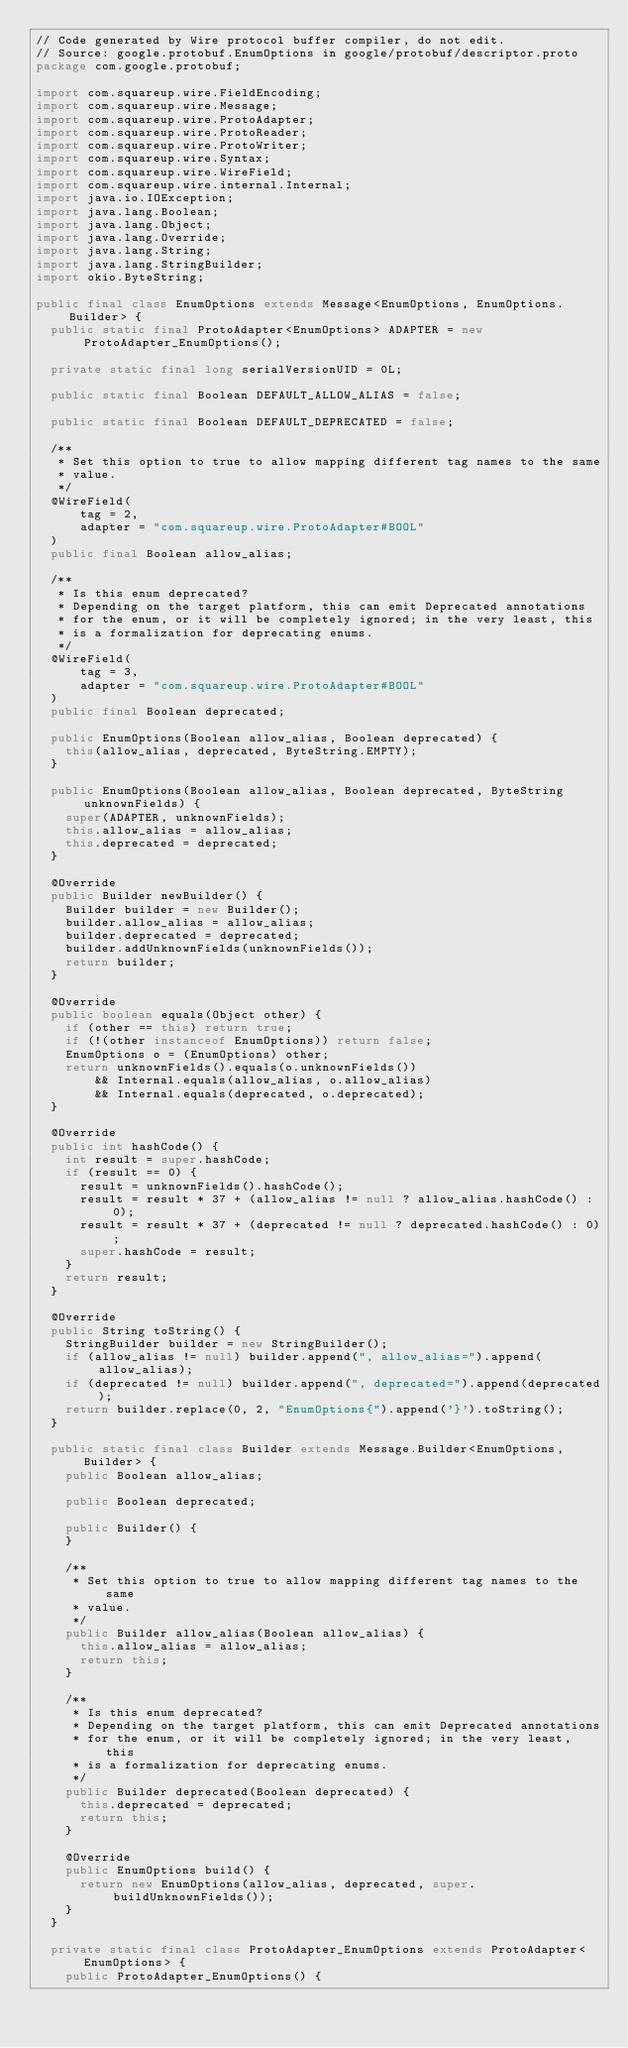Convert code to text. <code><loc_0><loc_0><loc_500><loc_500><_Java_>// Code generated by Wire protocol buffer compiler, do not edit.
// Source: google.protobuf.EnumOptions in google/protobuf/descriptor.proto
package com.google.protobuf;

import com.squareup.wire.FieldEncoding;
import com.squareup.wire.Message;
import com.squareup.wire.ProtoAdapter;
import com.squareup.wire.ProtoReader;
import com.squareup.wire.ProtoWriter;
import com.squareup.wire.Syntax;
import com.squareup.wire.WireField;
import com.squareup.wire.internal.Internal;
import java.io.IOException;
import java.lang.Boolean;
import java.lang.Object;
import java.lang.Override;
import java.lang.String;
import java.lang.StringBuilder;
import okio.ByteString;

public final class EnumOptions extends Message<EnumOptions, EnumOptions.Builder> {
  public static final ProtoAdapter<EnumOptions> ADAPTER = new ProtoAdapter_EnumOptions();

  private static final long serialVersionUID = 0L;

  public static final Boolean DEFAULT_ALLOW_ALIAS = false;

  public static final Boolean DEFAULT_DEPRECATED = false;

  /**
   * Set this option to true to allow mapping different tag names to the same
   * value.
   */
  @WireField(
      tag = 2,
      adapter = "com.squareup.wire.ProtoAdapter#BOOL"
  )
  public final Boolean allow_alias;

  /**
   * Is this enum deprecated?
   * Depending on the target platform, this can emit Deprecated annotations
   * for the enum, or it will be completely ignored; in the very least, this
   * is a formalization for deprecating enums.
   */
  @WireField(
      tag = 3,
      adapter = "com.squareup.wire.ProtoAdapter#BOOL"
  )
  public final Boolean deprecated;

  public EnumOptions(Boolean allow_alias, Boolean deprecated) {
    this(allow_alias, deprecated, ByteString.EMPTY);
  }

  public EnumOptions(Boolean allow_alias, Boolean deprecated, ByteString unknownFields) {
    super(ADAPTER, unknownFields);
    this.allow_alias = allow_alias;
    this.deprecated = deprecated;
  }

  @Override
  public Builder newBuilder() {
    Builder builder = new Builder();
    builder.allow_alias = allow_alias;
    builder.deprecated = deprecated;
    builder.addUnknownFields(unknownFields());
    return builder;
  }

  @Override
  public boolean equals(Object other) {
    if (other == this) return true;
    if (!(other instanceof EnumOptions)) return false;
    EnumOptions o = (EnumOptions) other;
    return unknownFields().equals(o.unknownFields())
        && Internal.equals(allow_alias, o.allow_alias)
        && Internal.equals(deprecated, o.deprecated);
  }

  @Override
  public int hashCode() {
    int result = super.hashCode;
    if (result == 0) {
      result = unknownFields().hashCode();
      result = result * 37 + (allow_alias != null ? allow_alias.hashCode() : 0);
      result = result * 37 + (deprecated != null ? deprecated.hashCode() : 0);
      super.hashCode = result;
    }
    return result;
  }

  @Override
  public String toString() {
    StringBuilder builder = new StringBuilder();
    if (allow_alias != null) builder.append(", allow_alias=").append(allow_alias);
    if (deprecated != null) builder.append(", deprecated=").append(deprecated);
    return builder.replace(0, 2, "EnumOptions{").append('}').toString();
  }

  public static final class Builder extends Message.Builder<EnumOptions, Builder> {
    public Boolean allow_alias;

    public Boolean deprecated;

    public Builder() {
    }

    /**
     * Set this option to true to allow mapping different tag names to the same
     * value.
     */
    public Builder allow_alias(Boolean allow_alias) {
      this.allow_alias = allow_alias;
      return this;
    }

    /**
     * Is this enum deprecated?
     * Depending on the target platform, this can emit Deprecated annotations
     * for the enum, or it will be completely ignored; in the very least, this
     * is a formalization for deprecating enums.
     */
    public Builder deprecated(Boolean deprecated) {
      this.deprecated = deprecated;
      return this;
    }

    @Override
    public EnumOptions build() {
      return new EnumOptions(allow_alias, deprecated, super.buildUnknownFields());
    }
  }

  private static final class ProtoAdapter_EnumOptions extends ProtoAdapter<EnumOptions> {
    public ProtoAdapter_EnumOptions() {</code> 